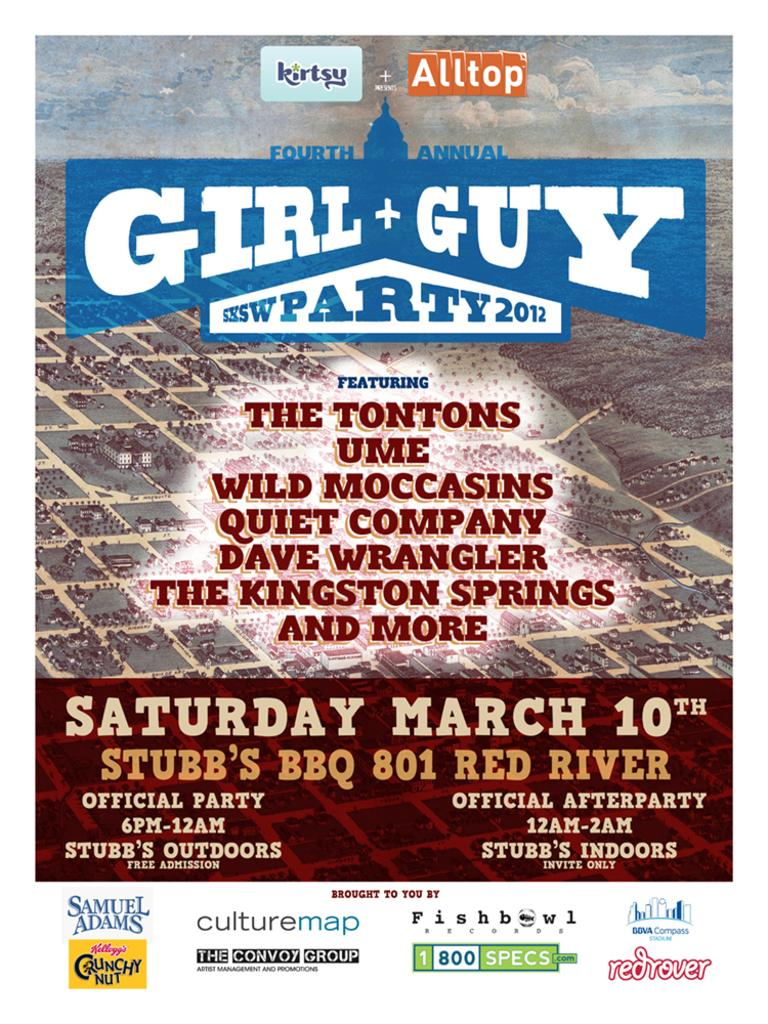<image>
Describe the image concisely. a poster for an event that is on Saturday March 10th 